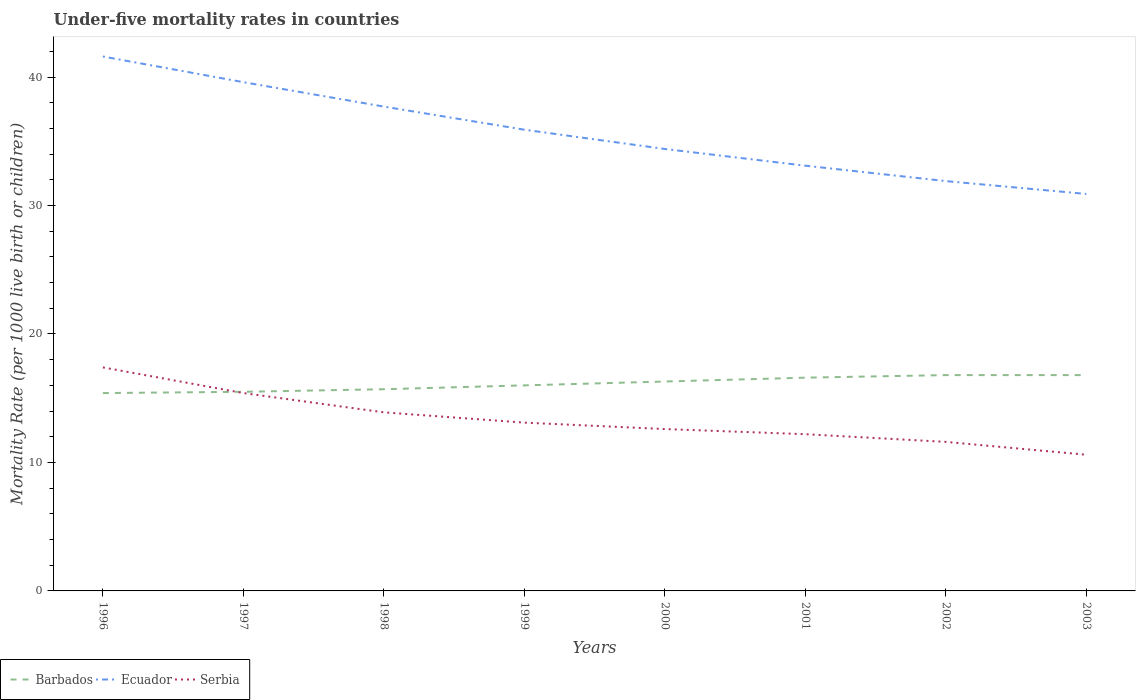How many different coloured lines are there?
Ensure brevity in your answer.  3. Does the line corresponding to Serbia intersect with the line corresponding to Ecuador?
Offer a terse response. No. Is the number of lines equal to the number of legend labels?
Your answer should be compact. Yes. Across all years, what is the maximum under-five mortality rate in Serbia?
Provide a short and direct response. 10.6. In which year was the under-five mortality rate in Barbados maximum?
Offer a terse response. 1996. What is the total under-five mortality rate in Barbados in the graph?
Offer a terse response. -0.2. What is the difference between the highest and the second highest under-five mortality rate in Barbados?
Ensure brevity in your answer.  1.4. Is the under-five mortality rate in Ecuador strictly greater than the under-five mortality rate in Serbia over the years?
Keep it short and to the point. No. What is the difference between two consecutive major ticks on the Y-axis?
Your answer should be very brief. 10. Are the values on the major ticks of Y-axis written in scientific E-notation?
Your response must be concise. No. Does the graph contain grids?
Ensure brevity in your answer.  No. Where does the legend appear in the graph?
Your answer should be compact. Bottom left. How are the legend labels stacked?
Make the answer very short. Horizontal. What is the title of the graph?
Provide a short and direct response. Under-five mortality rates in countries. What is the label or title of the X-axis?
Ensure brevity in your answer.  Years. What is the label or title of the Y-axis?
Keep it short and to the point. Mortality Rate (per 1000 live birth or children). What is the Mortality Rate (per 1000 live birth or children) of Ecuador in 1996?
Keep it short and to the point. 41.6. What is the Mortality Rate (per 1000 live birth or children) in Barbados in 1997?
Make the answer very short. 15.5. What is the Mortality Rate (per 1000 live birth or children) of Ecuador in 1997?
Provide a succinct answer. 39.6. What is the Mortality Rate (per 1000 live birth or children) of Barbados in 1998?
Offer a terse response. 15.7. What is the Mortality Rate (per 1000 live birth or children) of Ecuador in 1998?
Offer a terse response. 37.7. What is the Mortality Rate (per 1000 live birth or children) of Ecuador in 1999?
Provide a short and direct response. 35.9. What is the Mortality Rate (per 1000 live birth or children) of Barbados in 2000?
Give a very brief answer. 16.3. What is the Mortality Rate (per 1000 live birth or children) of Ecuador in 2000?
Give a very brief answer. 34.4. What is the Mortality Rate (per 1000 live birth or children) in Serbia in 2000?
Provide a succinct answer. 12.6. What is the Mortality Rate (per 1000 live birth or children) in Ecuador in 2001?
Provide a succinct answer. 33.1. What is the Mortality Rate (per 1000 live birth or children) in Barbados in 2002?
Your answer should be very brief. 16.8. What is the Mortality Rate (per 1000 live birth or children) of Ecuador in 2002?
Keep it short and to the point. 31.9. What is the Mortality Rate (per 1000 live birth or children) in Serbia in 2002?
Your answer should be compact. 11.6. What is the Mortality Rate (per 1000 live birth or children) in Ecuador in 2003?
Offer a terse response. 30.9. What is the Mortality Rate (per 1000 live birth or children) in Serbia in 2003?
Offer a terse response. 10.6. Across all years, what is the maximum Mortality Rate (per 1000 live birth or children) in Ecuador?
Your answer should be very brief. 41.6. Across all years, what is the minimum Mortality Rate (per 1000 live birth or children) in Ecuador?
Provide a short and direct response. 30.9. Across all years, what is the minimum Mortality Rate (per 1000 live birth or children) in Serbia?
Provide a short and direct response. 10.6. What is the total Mortality Rate (per 1000 live birth or children) of Barbados in the graph?
Offer a very short reply. 129.1. What is the total Mortality Rate (per 1000 live birth or children) in Ecuador in the graph?
Offer a very short reply. 285.1. What is the total Mortality Rate (per 1000 live birth or children) of Serbia in the graph?
Your answer should be compact. 106.8. What is the difference between the Mortality Rate (per 1000 live birth or children) in Barbados in 1996 and that in 1997?
Make the answer very short. -0.1. What is the difference between the Mortality Rate (per 1000 live birth or children) in Ecuador in 1996 and that in 1997?
Offer a terse response. 2. What is the difference between the Mortality Rate (per 1000 live birth or children) in Serbia in 1996 and that in 1997?
Your answer should be very brief. 2. What is the difference between the Mortality Rate (per 1000 live birth or children) of Ecuador in 1996 and that in 1998?
Give a very brief answer. 3.9. What is the difference between the Mortality Rate (per 1000 live birth or children) of Serbia in 1996 and that in 1998?
Give a very brief answer. 3.5. What is the difference between the Mortality Rate (per 1000 live birth or children) in Barbados in 1996 and that in 1999?
Make the answer very short. -0.6. What is the difference between the Mortality Rate (per 1000 live birth or children) of Barbados in 1996 and that in 2000?
Keep it short and to the point. -0.9. What is the difference between the Mortality Rate (per 1000 live birth or children) in Ecuador in 1996 and that in 2000?
Your answer should be very brief. 7.2. What is the difference between the Mortality Rate (per 1000 live birth or children) in Serbia in 1996 and that in 2000?
Offer a terse response. 4.8. What is the difference between the Mortality Rate (per 1000 live birth or children) of Barbados in 1996 and that in 2002?
Your answer should be very brief. -1.4. What is the difference between the Mortality Rate (per 1000 live birth or children) in Serbia in 1996 and that in 2002?
Give a very brief answer. 5.8. What is the difference between the Mortality Rate (per 1000 live birth or children) in Serbia in 1996 and that in 2003?
Ensure brevity in your answer.  6.8. What is the difference between the Mortality Rate (per 1000 live birth or children) of Ecuador in 1997 and that in 1998?
Make the answer very short. 1.9. What is the difference between the Mortality Rate (per 1000 live birth or children) in Serbia in 1997 and that in 1998?
Keep it short and to the point. 1.5. What is the difference between the Mortality Rate (per 1000 live birth or children) in Barbados in 1997 and that in 1999?
Provide a succinct answer. -0.5. What is the difference between the Mortality Rate (per 1000 live birth or children) of Barbados in 1997 and that in 2000?
Make the answer very short. -0.8. What is the difference between the Mortality Rate (per 1000 live birth or children) of Ecuador in 1997 and that in 2000?
Provide a succinct answer. 5.2. What is the difference between the Mortality Rate (per 1000 live birth or children) in Serbia in 1997 and that in 2000?
Make the answer very short. 2.8. What is the difference between the Mortality Rate (per 1000 live birth or children) of Barbados in 1997 and that in 2001?
Provide a succinct answer. -1.1. What is the difference between the Mortality Rate (per 1000 live birth or children) in Serbia in 1997 and that in 2001?
Provide a short and direct response. 3.2. What is the difference between the Mortality Rate (per 1000 live birth or children) of Barbados in 1997 and that in 2002?
Provide a short and direct response. -1.3. What is the difference between the Mortality Rate (per 1000 live birth or children) of Ecuador in 1997 and that in 2002?
Your answer should be compact. 7.7. What is the difference between the Mortality Rate (per 1000 live birth or children) of Barbados in 1997 and that in 2003?
Offer a very short reply. -1.3. What is the difference between the Mortality Rate (per 1000 live birth or children) of Serbia in 1997 and that in 2003?
Your answer should be very brief. 4.8. What is the difference between the Mortality Rate (per 1000 live birth or children) of Barbados in 1998 and that in 1999?
Keep it short and to the point. -0.3. What is the difference between the Mortality Rate (per 1000 live birth or children) in Barbados in 1998 and that in 2000?
Your answer should be compact. -0.6. What is the difference between the Mortality Rate (per 1000 live birth or children) in Serbia in 1998 and that in 2000?
Provide a short and direct response. 1.3. What is the difference between the Mortality Rate (per 1000 live birth or children) in Barbados in 1998 and that in 2001?
Provide a short and direct response. -0.9. What is the difference between the Mortality Rate (per 1000 live birth or children) of Ecuador in 1998 and that in 2001?
Offer a terse response. 4.6. What is the difference between the Mortality Rate (per 1000 live birth or children) in Ecuador in 1998 and that in 2002?
Make the answer very short. 5.8. What is the difference between the Mortality Rate (per 1000 live birth or children) of Serbia in 1998 and that in 2002?
Make the answer very short. 2.3. What is the difference between the Mortality Rate (per 1000 live birth or children) in Serbia in 1998 and that in 2003?
Your response must be concise. 3.3. What is the difference between the Mortality Rate (per 1000 live birth or children) of Ecuador in 1999 and that in 2000?
Provide a short and direct response. 1.5. What is the difference between the Mortality Rate (per 1000 live birth or children) in Barbados in 1999 and that in 2001?
Your answer should be very brief. -0.6. What is the difference between the Mortality Rate (per 1000 live birth or children) of Serbia in 1999 and that in 2003?
Your response must be concise. 2.5. What is the difference between the Mortality Rate (per 1000 live birth or children) in Barbados in 2000 and that in 2001?
Provide a short and direct response. -0.3. What is the difference between the Mortality Rate (per 1000 live birth or children) in Serbia in 2000 and that in 2001?
Offer a terse response. 0.4. What is the difference between the Mortality Rate (per 1000 live birth or children) in Barbados in 2000 and that in 2002?
Provide a succinct answer. -0.5. What is the difference between the Mortality Rate (per 1000 live birth or children) of Ecuador in 2000 and that in 2002?
Your answer should be compact. 2.5. What is the difference between the Mortality Rate (per 1000 live birth or children) in Serbia in 2000 and that in 2002?
Your response must be concise. 1. What is the difference between the Mortality Rate (per 1000 live birth or children) of Barbados in 2000 and that in 2003?
Make the answer very short. -0.5. What is the difference between the Mortality Rate (per 1000 live birth or children) in Ecuador in 2000 and that in 2003?
Your answer should be compact. 3.5. What is the difference between the Mortality Rate (per 1000 live birth or children) in Serbia in 2000 and that in 2003?
Make the answer very short. 2. What is the difference between the Mortality Rate (per 1000 live birth or children) of Ecuador in 2001 and that in 2003?
Keep it short and to the point. 2.2. What is the difference between the Mortality Rate (per 1000 live birth or children) of Serbia in 2001 and that in 2003?
Ensure brevity in your answer.  1.6. What is the difference between the Mortality Rate (per 1000 live birth or children) in Barbados in 2002 and that in 2003?
Offer a terse response. 0. What is the difference between the Mortality Rate (per 1000 live birth or children) in Ecuador in 2002 and that in 2003?
Your answer should be very brief. 1. What is the difference between the Mortality Rate (per 1000 live birth or children) in Barbados in 1996 and the Mortality Rate (per 1000 live birth or children) in Ecuador in 1997?
Provide a short and direct response. -24.2. What is the difference between the Mortality Rate (per 1000 live birth or children) of Barbados in 1996 and the Mortality Rate (per 1000 live birth or children) of Serbia in 1997?
Keep it short and to the point. 0. What is the difference between the Mortality Rate (per 1000 live birth or children) in Ecuador in 1996 and the Mortality Rate (per 1000 live birth or children) in Serbia in 1997?
Offer a very short reply. 26.2. What is the difference between the Mortality Rate (per 1000 live birth or children) in Barbados in 1996 and the Mortality Rate (per 1000 live birth or children) in Ecuador in 1998?
Offer a very short reply. -22.3. What is the difference between the Mortality Rate (per 1000 live birth or children) of Ecuador in 1996 and the Mortality Rate (per 1000 live birth or children) of Serbia in 1998?
Keep it short and to the point. 27.7. What is the difference between the Mortality Rate (per 1000 live birth or children) in Barbados in 1996 and the Mortality Rate (per 1000 live birth or children) in Ecuador in 1999?
Your answer should be very brief. -20.5. What is the difference between the Mortality Rate (per 1000 live birth or children) in Ecuador in 1996 and the Mortality Rate (per 1000 live birth or children) in Serbia in 1999?
Give a very brief answer. 28.5. What is the difference between the Mortality Rate (per 1000 live birth or children) of Barbados in 1996 and the Mortality Rate (per 1000 live birth or children) of Ecuador in 2000?
Offer a terse response. -19. What is the difference between the Mortality Rate (per 1000 live birth or children) in Barbados in 1996 and the Mortality Rate (per 1000 live birth or children) in Ecuador in 2001?
Your answer should be compact. -17.7. What is the difference between the Mortality Rate (per 1000 live birth or children) in Barbados in 1996 and the Mortality Rate (per 1000 live birth or children) in Serbia in 2001?
Provide a short and direct response. 3.2. What is the difference between the Mortality Rate (per 1000 live birth or children) of Ecuador in 1996 and the Mortality Rate (per 1000 live birth or children) of Serbia in 2001?
Ensure brevity in your answer.  29.4. What is the difference between the Mortality Rate (per 1000 live birth or children) in Barbados in 1996 and the Mortality Rate (per 1000 live birth or children) in Ecuador in 2002?
Make the answer very short. -16.5. What is the difference between the Mortality Rate (per 1000 live birth or children) in Barbados in 1996 and the Mortality Rate (per 1000 live birth or children) in Serbia in 2002?
Ensure brevity in your answer.  3.8. What is the difference between the Mortality Rate (per 1000 live birth or children) in Barbados in 1996 and the Mortality Rate (per 1000 live birth or children) in Ecuador in 2003?
Provide a short and direct response. -15.5. What is the difference between the Mortality Rate (per 1000 live birth or children) in Barbados in 1996 and the Mortality Rate (per 1000 live birth or children) in Serbia in 2003?
Provide a succinct answer. 4.8. What is the difference between the Mortality Rate (per 1000 live birth or children) in Ecuador in 1996 and the Mortality Rate (per 1000 live birth or children) in Serbia in 2003?
Provide a short and direct response. 31. What is the difference between the Mortality Rate (per 1000 live birth or children) of Barbados in 1997 and the Mortality Rate (per 1000 live birth or children) of Ecuador in 1998?
Offer a terse response. -22.2. What is the difference between the Mortality Rate (per 1000 live birth or children) of Barbados in 1997 and the Mortality Rate (per 1000 live birth or children) of Serbia in 1998?
Give a very brief answer. 1.6. What is the difference between the Mortality Rate (per 1000 live birth or children) of Ecuador in 1997 and the Mortality Rate (per 1000 live birth or children) of Serbia in 1998?
Provide a short and direct response. 25.7. What is the difference between the Mortality Rate (per 1000 live birth or children) of Barbados in 1997 and the Mortality Rate (per 1000 live birth or children) of Ecuador in 1999?
Provide a short and direct response. -20.4. What is the difference between the Mortality Rate (per 1000 live birth or children) in Barbados in 1997 and the Mortality Rate (per 1000 live birth or children) in Ecuador in 2000?
Ensure brevity in your answer.  -18.9. What is the difference between the Mortality Rate (per 1000 live birth or children) of Barbados in 1997 and the Mortality Rate (per 1000 live birth or children) of Ecuador in 2001?
Make the answer very short. -17.6. What is the difference between the Mortality Rate (per 1000 live birth or children) of Barbados in 1997 and the Mortality Rate (per 1000 live birth or children) of Serbia in 2001?
Offer a terse response. 3.3. What is the difference between the Mortality Rate (per 1000 live birth or children) of Ecuador in 1997 and the Mortality Rate (per 1000 live birth or children) of Serbia in 2001?
Your response must be concise. 27.4. What is the difference between the Mortality Rate (per 1000 live birth or children) in Barbados in 1997 and the Mortality Rate (per 1000 live birth or children) in Ecuador in 2002?
Your answer should be compact. -16.4. What is the difference between the Mortality Rate (per 1000 live birth or children) in Barbados in 1997 and the Mortality Rate (per 1000 live birth or children) in Serbia in 2002?
Offer a terse response. 3.9. What is the difference between the Mortality Rate (per 1000 live birth or children) in Ecuador in 1997 and the Mortality Rate (per 1000 live birth or children) in Serbia in 2002?
Ensure brevity in your answer.  28. What is the difference between the Mortality Rate (per 1000 live birth or children) in Barbados in 1997 and the Mortality Rate (per 1000 live birth or children) in Ecuador in 2003?
Give a very brief answer. -15.4. What is the difference between the Mortality Rate (per 1000 live birth or children) of Barbados in 1998 and the Mortality Rate (per 1000 live birth or children) of Ecuador in 1999?
Your answer should be very brief. -20.2. What is the difference between the Mortality Rate (per 1000 live birth or children) in Ecuador in 1998 and the Mortality Rate (per 1000 live birth or children) in Serbia in 1999?
Keep it short and to the point. 24.6. What is the difference between the Mortality Rate (per 1000 live birth or children) in Barbados in 1998 and the Mortality Rate (per 1000 live birth or children) in Ecuador in 2000?
Offer a very short reply. -18.7. What is the difference between the Mortality Rate (per 1000 live birth or children) in Ecuador in 1998 and the Mortality Rate (per 1000 live birth or children) in Serbia in 2000?
Ensure brevity in your answer.  25.1. What is the difference between the Mortality Rate (per 1000 live birth or children) of Barbados in 1998 and the Mortality Rate (per 1000 live birth or children) of Ecuador in 2001?
Give a very brief answer. -17.4. What is the difference between the Mortality Rate (per 1000 live birth or children) of Ecuador in 1998 and the Mortality Rate (per 1000 live birth or children) of Serbia in 2001?
Ensure brevity in your answer.  25.5. What is the difference between the Mortality Rate (per 1000 live birth or children) of Barbados in 1998 and the Mortality Rate (per 1000 live birth or children) of Ecuador in 2002?
Give a very brief answer. -16.2. What is the difference between the Mortality Rate (per 1000 live birth or children) in Ecuador in 1998 and the Mortality Rate (per 1000 live birth or children) in Serbia in 2002?
Keep it short and to the point. 26.1. What is the difference between the Mortality Rate (per 1000 live birth or children) in Barbados in 1998 and the Mortality Rate (per 1000 live birth or children) in Ecuador in 2003?
Give a very brief answer. -15.2. What is the difference between the Mortality Rate (per 1000 live birth or children) in Ecuador in 1998 and the Mortality Rate (per 1000 live birth or children) in Serbia in 2003?
Your response must be concise. 27.1. What is the difference between the Mortality Rate (per 1000 live birth or children) in Barbados in 1999 and the Mortality Rate (per 1000 live birth or children) in Ecuador in 2000?
Offer a terse response. -18.4. What is the difference between the Mortality Rate (per 1000 live birth or children) in Barbados in 1999 and the Mortality Rate (per 1000 live birth or children) in Serbia in 2000?
Your response must be concise. 3.4. What is the difference between the Mortality Rate (per 1000 live birth or children) in Ecuador in 1999 and the Mortality Rate (per 1000 live birth or children) in Serbia in 2000?
Your response must be concise. 23.3. What is the difference between the Mortality Rate (per 1000 live birth or children) of Barbados in 1999 and the Mortality Rate (per 1000 live birth or children) of Ecuador in 2001?
Keep it short and to the point. -17.1. What is the difference between the Mortality Rate (per 1000 live birth or children) in Barbados in 1999 and the Mortality Rate (per 1000 live birth or children) in Serbia in 2001?
Your answer should be very brief. 3.8. What is the difference between the Mortality Rate (per 1000 live birth or children) of Ecuador in 1999 and the Mortality Rate (per 1000 live birth or children) of Serbia in 2001?
Offer a very short reply. 23.7. What is the difference between the Mortality Rate (per 1000 live birth or children) of Barbados in 1999 and the Mortality Rate (per 1000 live birth or children) of Ecuador in 2002?
Your response must be concise. -15.9. What is the difference between the Mortality Rate (per 1000 live birth or children) in Ecuador in 1999 and the Mortality Rate (per 1000 live birth or children) in Serbia in 2002?
Provide a short and direct response. 24.3. What is the difference between the Mortality Rate (per 1000 live birth or children) of Barbados in 1999 and the Mortality Rate (per 1000 live birth or children) of Ecuador in 2003?
Offer a very short reply. -14.9. What is the difference between the Mortality Rate (per 1000 live birth or children) in Barbados in 1999 and the Mortality Rate (per 1000 live birth or children) in Serbia in 2003?
Make the answer very short. 5.4. What is the difference between the Mortality Rate (per 1000 live birth or children) in Ecuador in 1999 and the Mortality Rate (per 1000 live birth or children) in Serbia in 2003?
Provide a short and direct response. 25.3. What is the difference between the Mortality Rate (per 1000 live birth or children) in Barbados in 2000 and the Mortality Rate (per 1000 live birth or children) in Ecuador in 2001?
Give a very brief answer. -16.8. What is the difference between the Mortality Rate (per 1000 live birth or children) of Barbados in 2000 and the Mortality Rate (per 1000 live birth or children) of Serbia in 2001?
Your answer should be very brief. 4.1. What is the difference between the Mortality Rate (per 1000 live birth or children) in Barbados in 2000 and the Mortality Rate (per 1000 live birth or children) in Ecuador in 2002?
Give a very brief answer. -15.6. What is the difference between the Mortality Rate (per 1000 live birth or children) of Ecuador in 2000 and the Mortality Rate (per 1000 live birth or children) of Serbia in 2002?
Ensure brevity in your answer.  22.8. What is the difference between the Mortality Rate (per 1000 live birth or children) in Barbados in 2000 and the Mortality Rate (per 1000 live birth or children) in Ecuador in 2003?
Ensure brevity in your answer.  -14.6. What is the difference between the Mortality Rate (per 1000 live birth or children) of Ecuador in 2000 and the Mortality Rate (per 1000 live birth or children) of Serbia in 2003?
Make the answer very short. 23.8. What is the difference between the Mortality Rate (per 1000 live birth or children) in Barbados in 2001 and the Mortality Rate (per 1000 live birth or children) in Ecuador in 2002?
Provide a succinct answer. -15.3. What is the difference between the Mortality Rate (per 1000 live birth or children) of Barbados in 2001 and the Mortality Rate (per 1000 live birth or children) of Serbia in 2002?
Make the answer very short. 5. What is the difference between the Mortality Rate (per 1000 live birth or children) of Barbados in 2001 and the Mortality Rate (per 1000 live birth or children) of Ecuador in 2003?
Provide a short and direct response. -14.3. What is the difference between the Mortality Rate (per 1000 live birth or children) in Ecuador in 2001 and the Mortality Rate (per 1000 live birth or children) in Serbia in 2003?
Provide a short and direct response. 22.5. What is the difference between the Mortality Rate (per 1000 live birth or children) of Barbados in 2002 and the Mortality Rate (per 1000 live birth or children) of Ecuador in 2003?
Keep it short and to the point. -14.1. What is the difference between the Mortality Rate (per 1000 live birth or children) of Barbados in 2002 and the Mortality Rate (per 1000 live birth or children) of Serbia in 2003?
Your answer should be compact. 6.2. What is the difference between the Mortality Rate (per 1000 live birth or children) in Ecuador in 2002 and the Mortality Rate (per 1000 live birth or children) in Serbia in 2003?
Your response must be concise. 21.3. What is the average Mortality Rate (per 1000 live birth or children) in Barbados per year?
Your answer should be compact. 16.14. What is the average Mortality Rate (per 1000 live birth or children) in Ecuador per year?
Keep it short and to the point. 35.64. What is the average Mortality Rate (per 1000 live birth or children) in Serbia per year?
Offer a terse response. 13.35. In the year 1996, what is the difference between the Mortality Rate (per 1000 live birth or children) of Barbados and Mortality Rate (per 1000 live birth or children) of Ecuador?
Your answer should be compact. -26.2. In the year 1996, what is the difference between the Mortality Rate (per 1000 live birth or children) of Barbados and Mortality Rate (per 1000 live birth or children) of Serbia?
Your answer should be compact. -2. In the year 1996, what is the difference between the Mortality Rate (per 1000 live birth or children) of Ecuador and Mortality Rate (per 1000 live birth or children) of Serbia?
Your response must be concise. 24.2. In the year 1997, what is the difference between the Mortality Rate (per 1000 live birth or children) in Barbados and Mortality Rate (per 1000 live birth or children) in Ecuador?
Your response must be concise. -24.1. In the year 1997, what is the difference between the Mortality Rate (per 1000 live birth or children) of Barbados and Mortality Rate (per 1000 live birth or children) of Serbia?
Make the answer very short. 0.1. In the year 1997, what is the difference between the Mortality Rate (per 1000 live birth or children) of Ecuador and Mortality Rate (per 1000 live birth or children) of Serbia?
Make the answer very short. 24.2. In the year 1998, what is the difference between the Mortality Rate (per 1000 live birth or children) in Barbados and Mortality Rate (per 1000 live birth or children) in Ecuador?
Your response must be concise. -22. In the year 1998, what is the difference between the Mortality Rate (per 1000 live birth or children) in Barbados and Mortality Rate (per 1000 live birth or children) in Serbia?
Your answer should be compact. 1.8. In the year 1998, what is the difference between the Mortality Rate (per 1000 live birth or children) of Ecuador and Mortality Rate (per 1000 live birth or children) of Serbia?
Make the answer very short. 23.8. In the year 1999, what is the difference between the Mortality Rate (per 1000 live birth or children) of Barbados and Mortality Rate (per 1000 live birth or children) of Ecuador?
Your answer should be very brief. -19.9. In the year 1999, what is the difference between the Mortality Rate (per 1000 live birth or children) in Barbados and Mortality Rate (per 1000 live birth or children) in Serbia?
Provide a succinct answer. 2.9. In the year 1999, what is the difference between the Mortality Rate (per 1000 live birth or children) in Ecuador and Mortality Rate (per 1000 live birth or children) in Serbia?
Your answer should be very brief. 22.8. In the year 2000, what is the difference between the Mortality Rate (per 1000 live birth or children) of Barbados and Mortality Rate (per 1000 live birth or children) of Ecuador?
Provide a succinct answer. -18.1. In the year 2000, what is the difference between the Mortality Rate (per 1000 live birth or children) of Ecuador and Mortality Rate (per 1000 live birth or children) of Serbia?
Ensure brevity in your answer.  21.8. In the year 2001, what is the difference between the Mortality Rate (per 1000 live birth or children) of Barbados and Mortality Rate (per 1000 live birth or children) of Ecuador?
Keep it short and to the point. -16.5. In the year 2001, what is the difference between the Mortality Rate (per 1000 live birth or children) in Ecuador and Mortality Rate (per 1000 live birth or children) in Serbia?
Make the answer very short. 20.9. In the year 2002, what is the difference between the Mortality Rate (per 1000 live birth or children) of Barbados and Mortality Rate (per 1000 live birth or children) of Ecuador?
Your answer should be compact. -15.1. In the year 2002, what is the difference between the Mortality Rate (per 1000 live birth or children) of Barbados and Mortality Rate (per 1000 live birth or children) of Serbia?
Your answer should be compact. 5.2. In the year 2002, what is the difference between the Mortality Rate (per 1000 live birth or children) of Ecuador and Mortality Rate (per 1000 live birth or children) of Serbia?
Keep it short and to the point. 20.3. In the year 2003, what is the difference between the Mortality Rate (per 1000 live birth or children) in Barbados and Mortality Rate (per 1000 live birth or children) in Ecuador?
Provide a succinct answer. -14.1. In the year 2003, what is the difference between the Mortality Rate (per 1000 live birth or children) of Ecuador and Mortality Rate (per 1000 live birth or children) of Serbia?
Your answer should be very brief. 20.3. What is the ratio of the Mortality Rate (per 1000 live birth or children) in Ecuador in 1996 to that in 1997?
Give a very brief answer. 1.05. What is the ratio of the Mortality Rate (per 1000 live birth or children) of Serbia in 1996 to that in 1997?
Offer a very short reply. 1.13. What is the ratio of the Mortality Rate (per 1000 live birth or children) of Barbados in 1996 to that in 1998?
Offer a very short reply. 0.98. What is the ratio of the Mortality Rate (per 1000 live birth or children) in Ecuador in 1996 to that in 1998?
Your response must be concise. 1.1. What is the ratio of the Mortality Rate (per 1000 live birth or children) of Serbia in 1996 to that in 1998?
Provide a succinct answer. 1.25. What is the ratio of the Mortality Rate (per 1000 live birth or children) in Barbados in 1996 to that in 1999?
Offer a terse response. 0.96. What is the ratio of the Mortality Rate (per 1000 live birth or children) in Ecuador in 1996 to that in 1999?
Provide a short and direct response. 1.16. What is the ratio of the Mortality Rate (per 1000 live birth or children) in Serbia in 1996 to that in 1999?
Ensure brevity in your answer.  1.33. What is the ratio of the Mortality Rate (per 1000 live birth or children) of Barbados in 1996 to that in 2000?
Keep it short and to the point. 0.94. What is the ratio of the Mortality Rate (per 1000 live birth or children) of Ecuador in 1996 to that in 2000?
Your answer should be very brief. 1.21. What is the ratio of the Mortality Rate (per 1000 live birth or children) in Serbia in 1996 to that in 2000?
Offer a terse response. 1.38. What is the ratio of the Mortality Rate (per 1000 live birth or children) in Barbados in 1996 to that in 2001?
Keep it short and to the point. 0.93. What is the ratio of the Mortality Rate (per 1000 live birth or children) in Ecuador in 1996 to that in 2001?
Keep it short and to the point. 1.26. What is the ratio of the Mortality Rate (per 1000 live birth or children) of Serbia in 1996 to that in 2001?
Give a very brief answer. 1.43. What is the ratio of the Mortality Rate (per 1000 live birth or children) in Ecuador in 1996 to that in 2002?
Make the answer very short. 1.3. What is the ratio of the Mortality Rate (per 1000 live birth or children) of Ecuador in 1996 to that in 2003?
Offer a very short reply. 1.35. What is the ratio of the Mortality Rate (per 1000 live birth or children) in Serbia in 1996 to that in 2003?
Offer a very short reply. 1.64. What is the ratio of the Mortality Rate (per 1000 live birth or children) in Barbados in 1997 to that in 1998?
Your answer should be compact. 0.99. What is the ratio of the Mortality Rate (per 1000 live birth or children) in Ecuador in 1997 to that in 1998?
Provide a short and direct response. 1.05. What is the ratio of the Mortality Rate (per 1000 live birth or children) in Serbia in 1997 to that in 1998?
Give a very brief answer. 1.11. What is the ratio of the Mortality Rate (per 1000 live birth or children) of Barbados in 1997 to that in 1999?
Your answer should be very brief. 0.97. What is the ratio of the Mortality Rate (per 1000 live birth or children) of Ecuador in 1997 to that in 1999?
Offer a terse response. 1.1. What is the ratio of the Mortality Rate (per 1000 live birth or children) of Serbia in 1997 to that in 1999?
Make the answer very short. 1.18. What is the ratio of the Mortality Rate (per 1000 live birth or children) of Barbados in 1997 to that in 2000?
Your answer should be very brief. 0.95. What is the ratio of the Mortality Rate (per 1000 live birth or children) of Ecuador in 1997 to that in 2000?
Your response must be concise. 1.15. What is the ratio of the Mortality Rate (per 1000 live birth or children) in Serbia in 1997 to that in 2000?
Provide a short and direct response. 1.22. What is the ratio of the Mortality Rate (per 1000 live birth or children) of Barbados in 1997 to that in 2001?
Your answer should be very brief. 0.93. What is the ratio of the Mortality Rate (per 1000 live birth or children) in Ecuador in 1997 to that in 2001?
Your answer should be very brief. 1.2. What is the ratio of the Mortality Rate (per 1000 live birth or children) of Serbia in 1997 to that in 2001?
Keep it short and to the point. 1.26. What is the ratio of the Mortality Rate (per 1000 live birth or children) of Barbados in 1997 to that in 2002?
Offer a very short reply. 0.92. What is the ratio of the Mortality Rate (per 1000 live birth or children) of Ecuador in 1997 to that in 2002?
Your answer should be very brief. 1.24. What is the ratio of the Mortality Rate (per 1000 live birth or children) of Serbia in 1997 to that in 2002?
Your answer should be compact. 1.33. What is the ratio of the Mortality Rate (per 1000 live birth or children) in Barbados in 1997 to that in 2003?
Keep it short and to the point. 0.92. What is the ratio of the Mortality Rate (per 1000 live birth or children) of Ecuador in 1997 to that in 2003?
Offer a terse response. 1.28. What is the ratio of the Mortality Rate (per 1000 live birth or children) in Serbia in 1997 to that in 2003?
Make the answer very short. 1.45. What is the ratio of the Mortality Rate (per 1000 live birth or children) in Barbados in 1998 to that in 1999?
Give a very brief answer. 0.98. What is the ratio of the Mortality Rate (per 1000 live birth or children) in Ecuador in 1998 to that in 1999?
Offer a very short reply. 1.05. What is the ratio of the Mortality Rate (per 1000 live birth or children) in Serbia in 1998 to that in 1999?
Give a very brief answer. 1.06. What is the ratio of the Mortality Rate (per 1000 live birth or children) in Barbados in 1998 to that in 2000?
Your answer should be very brief. 0.96. What is the ratio of the Mortality Rate (per 1000 live birth or children) in Ecuador in 1998 to that in 2000?
Make the answer very short. 1.1. What is the ratio of the Mortality Rate (per 1000 live birth or children) in Serbia in 1998 to that in 2000?
Provide a short and direct response. 1.1. What is the ratio of the Mortality Rate (per 1000 live birth or children) in Barbados in 1998 to that in 2001?
Your answer should be compact. 0.95. What is the ratio of the Mortality Rate (per 1000 live birth or children) of Ecuador in 1998 to that in 2001?
Provide a short and direct response. 1.14. What is the ratio of the Mortality Rate (per 1000 live birth or children) in Serbia in 1998 to that in 2001?
Give a very brief answer. 1.14. What is the ratio of the Mortality Rate (per 1000 live birth or children) in Barbados in 1998 to that in 2002?
Offer a very short reply. 0.93. What is the ratio of the Mortality Rate (per 1000 live birth or children) of Ecuador in 1998 to that in 2002?
Offer a very short reply. 1.18. What is the ratio of the Mortality Rate (per 1000 live birth or children) of Serbia in 1998 to that in 2002?
Make the answer very short. 1.2. What is the ratio of the Mortality Rate (per 1000 live birth or children) in Barbados in 1998 to that in 2003?
Make the answer very short. 0.93. What is the ratio of the Mortality Rate (per 1000 live birth or children) of Ecuador in 1998 to that in 2003?
Give a very brief answer. 1.22. What is the ratio of the Mortality Rate (per 1000 live birth or children) of Serbia in 1998 to that in 2003?
Ensure brevity in your answer.  1.31. What is the ratio of the Mortality Rate (per 1000 live birth or children) in Barbados in 1999 to that in 2000?
Make the answer very short. 0.98. What is the ratio of the Mortality Rate (per 1000 live birth or children) in Ecuador in 1999 to that in 2000?
Provide a short and direct response. 1.04. What is the ratio of the Mortality Rate (per 1000 live birth or children) in Serbia in 1999 to that in 2000?
Make the answer very short. 1.04. What is the ratio of the Mortality Rate (per 1000 live birth or children) in Barbados in 1999 to that in 2001?
Provide a succinct answer. 0.96. What is the ratio of the Mortality Rate (per 1000 live birth or children) of Ecuador in 1999 to that in 2001?
Give a very brief answer. 1.08. What is the ratio of the Mortality Rate (per 1000 live birth or children) of Serbia in 1999 to that in 2001?
Your answer should be compact. 1.07. What is the ratio of the Mortality Rate (per 1000 live birth or children) of Barbados in 1999 to that in 2002?
Ensure brevity in your answer.  0.95. What is the ratio of the Mortality Rate (per 1000 live birth or children) in Ecuador in 1999 to that in 2002?
Keep it short and to the point. 1.13. What is the ratio of the Mortality Rate (per 1000 live birth or children) of Serbia in 1999 to that in 2002?
Your answer should be compact. 1.13. What is the ratio of the Mortality Rate (per 1000 live birth or children) of Ecuador in 1999 to that in 2003?
Provide a succinct answer. 1.16. What is the ratio of the Mortality Rate (per 1000 live birth or children) in Serbia in 1999 to that in 2003?
Give a very brief answer. 1.24. What is the ratio of the Mortality Rate (per 1000 live birth or children) of Barbados in 2000 to that in 2001?
Keep it short and to the point. 0.98. What is the ratio of the Mortality Rate (per 1000 live birth or children) of Ecuador in 2000 to that in 2001?
Your response must be concise. 1.04. What is the ratio of the Mortality Rate (per 1000 live birth or children) in Serbia in 2000 to that in 2001?
Provide a succinct answer. 1.03. What is the ratio of the Mortality Rate (per 1000 live birth or children) in Barbados in 2000 to that in 2002?
Your response must be concise. 0.97. What is the ratio of the Mortality Rate (per 1000 live birth or children) of Ecuador in 2000 to that in 2002?
Offer a very short reply. 1.08. What is the ratio of the Mortality Rate (per 1000 live birth or children) in Serbia in 2000 to that in 2002?
Keep it short and to the point. 1.09. What is the ratio of the Mortality Rate (per 1000 live birth or children) in Barbados in 2000 to that in 2003?
Provide a succinct answer. 0.97. What is the ratio of the Mortality Rate (per 1000 live birth or children) in Ecuador in 2000 to that in 2003?
Make the answer very short. 1.11. What is the ratio of the Mortality Rate (per 1000 live birth or children) of Serbia in 2000 to that in 2003?
Keep it short and to the point. 1.19. What is the ratio of the Mortality Rate (per 1000 live birth or children) of Barbados in 2001 to that in 2002?
Provide a short and direct response. 0.99. What is the ratio of the Mortality Rate (per 1000 live birth or children) of Ecuador in 2001 to that in 2002?
Offer a very short reply. 1.04. What is the ratio of the Mortality Rate (per 1000 live birth or children) in Serbia in 2001 to that in 2002?
Offer a terse response. 1.05. What is the ratio of the Mortality Rate (per 1000 live birth or children) of Ecuador in 2001 to that in 2003?
Offer a terse response. 1.07. What is the ratio of the Mortality Rate (per 1000 live birth or children) in Serbia in 2001 to that in 2003?
Provide a short and direct response. 1.15. What is the ratio of the Mortality Rate (per 1000 live birth or children) in Barbados in 2002 to that in 2003?
Give a very brief answer. 1. What is the ratio of the Mortality Rate (per 1000 live birth or children) in Ecuador in 2002 to that in 2003?
Provide a short and direct response. 1.03. What is the ratio of the Mortality Rate (per 1000 live birth or children) of Serbia in 2002 to that in 2003?
Provide a short and direct response. 1.09. What is the difference between the highest and the second highest Mortality Rate (per 1000 live birth or children) of Ecuador?
Offer a terse response. 2. What is the difference between the highest and the second highest Mortality Rate (per 1000 live birth or children) in Serbia?
Provide a short and direct response. 2. What is the difference between the highest and the lowest Mortality Rate (per 1000 live birth or children) in Barbados?
Your answer should be compact. 1.4. What is the difference between the highest and the lowest Mortality Rate (per 1000 live birth or children) in Ecuador?
Give a very brief answer. 10.7. 